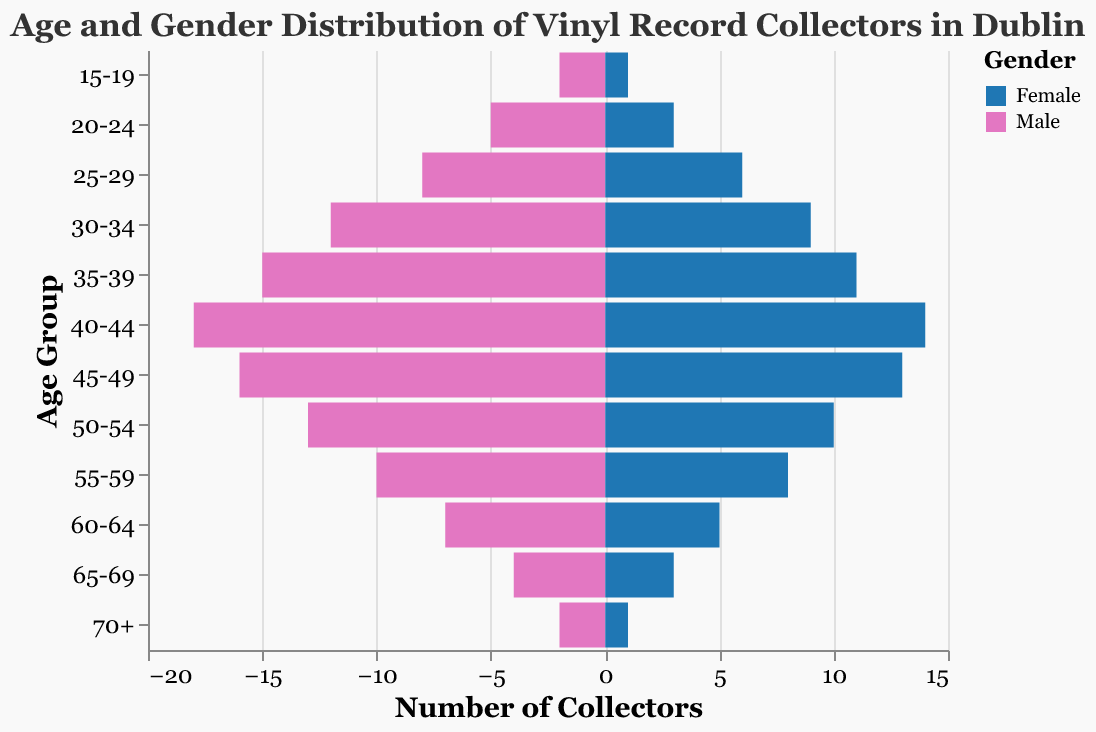What's the title of the figure? The title is displayed at the top of the figure and provides an overview of what the chart represents.
Answer: Age and Gender Distribution of Vinyl Record Collectors in Dublin What are the colors used to represent males and females? The colors indicated in the legend distinguish between males and females.
Answer: Blue for males and pink for females Which age group has the highest number of male collectors? Look for the age group where the blue bar extends the furthest to the left.
Answer: 40-44 How many female collectors are in the 30-34 age group? Refer to the pink bar aligned with the 30-34 age group and note the number next to the bar.
Answer: 9 What's the total number of collectors in the 50-54 age group? Add the counts of male and female collectors for the 50-54 age group.
Answer: 23 Which age group has the smallest number of vinyl record collectors? Identify the age group with the shortest combined length of blue and pink bars.
Answer: 15-19 or 70+ How does the number of female collectors in the 45-49 age group compare to the 55-59 age group? Compare the lengths of the pink bars for the 45-49 and 55-59 age groups.
Answer: There are more female collectors in the 45-49 age group What is the difference in the number of collectors between the 60-64 and 65-69 age groups? Calculate the difference by summing the male and female counts for each group and subtracting one total from the other.
Answer: 4 (12 for 60-64 and 8 for 65-69) Is there any age group where the number of male and female collectors is equal? Check each age group to see if the lengths of the blue and pink bars are the same.
Answer: No How many more male collectors are there than female collectors in the 35-39 age group? Subtract the number of female collectors from the number of male collectors in the 35-39 age group.
Answer: 4 